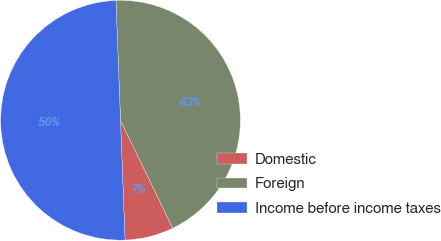Convert chart to OTSL. <chart><loc_0><loc_0><loc_500><loc_500><pie_chart><fcel>Domestic<fcel>Foreign<fcel>Income before income taxes<nl><fcel>6.57%<fcel>43.43%<fcel>50.0%<nl></chart> 